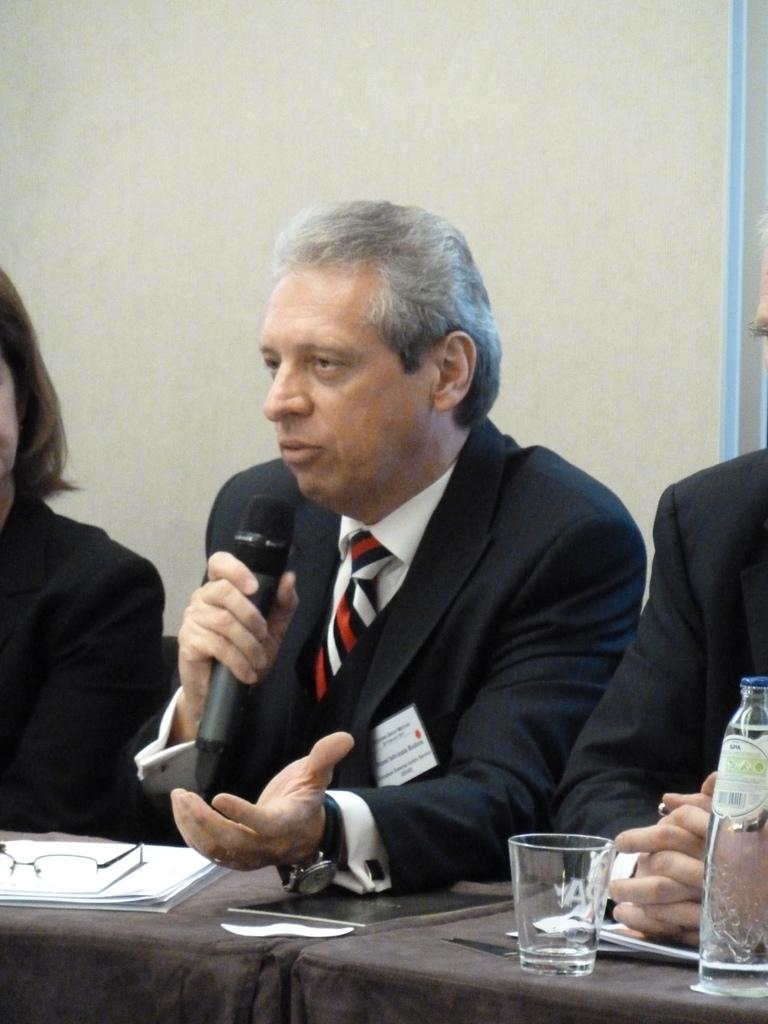Who is the main subject in the image? There is a man in the middle of the image. What is the man doing in the image? The man is sitting and holding a microphone. What is the man doing with the microphone? The man is speaking into the microphone. What can be seen in the background of the image? There is a white color wall in the background of the image. What is the man's temper like in the image? There is no information about the man's temper in the image. The image only shows the man sitting, holding a microphone, and speaking into it. 